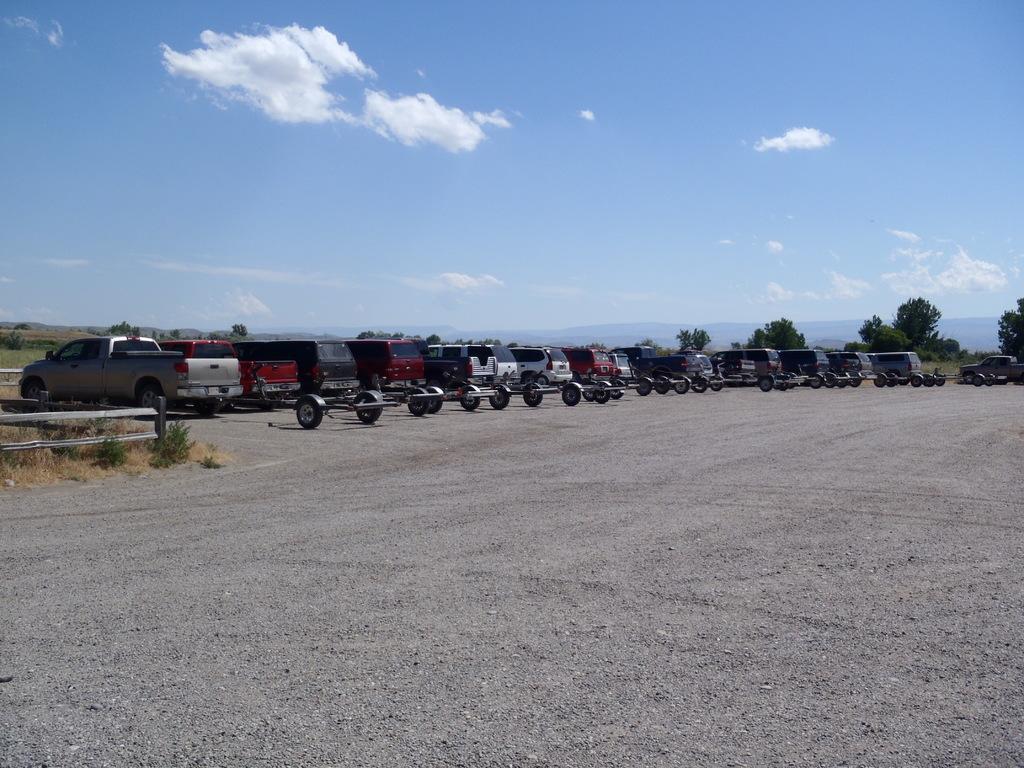In one or two sentences, can you explain what this image depicts? In this picture we can see vehicle on the ground and in the background we can see trees, mountains and sky with clouds. 